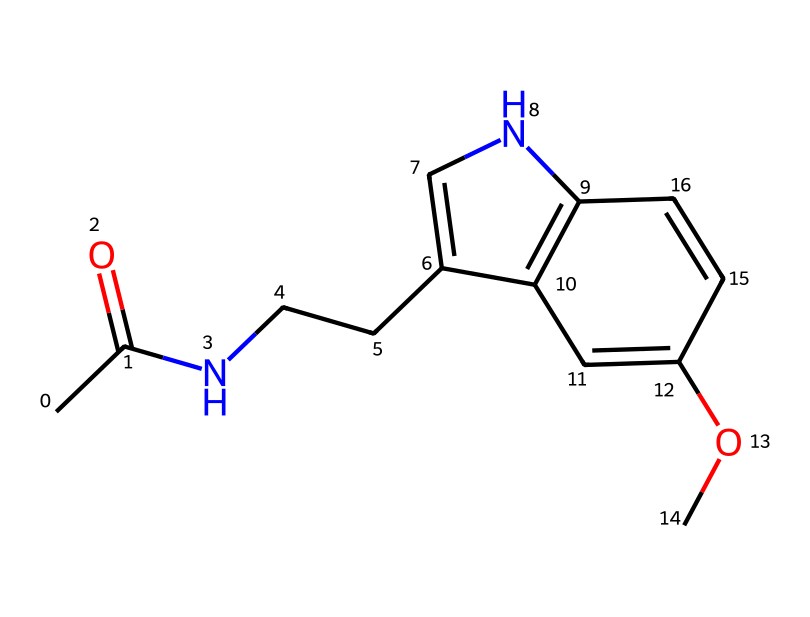how many carbon atoms are in the structure? By examining the SMILES representation, we can count the number of 'C' characters, which represent carbon atoms. In this case, there are 11 carbon atoms present in the structure.
Answer: 11 what is the functional group present in melatonin? Looking at the structure, we can identify that there is an amide group (-C(=O)N-) at the beginning of the SMILES representation, which is a key functional group in melatonin responsible for its biological activity.
Answer: amide what is the total number of nitrogen atoms in this chemical? In the SMILES representation, the nitrogen atoms are represented by the 'N' characters. By counting them, we find that there are 2 nitrogen atoms in the structure of melatonin.
Answer: 2 which bond type is primarily present between carbon and nitrogen in melatonin? The connection between carbon and nitrogen in the amide functional group indicates a covalent bond, which is typically present in organic molecules like melatonin.
Answer: covalent does melatonin contain a methoxy group? The presence of the structure 'OC' in the SMILES indicates a methoxy group (-OCH3), confirming that melatonin indeed contains this functional group characterized by a carbon atom bonded to an oxygen atom.
Answer: yes what is the molecular weight of melatonin? To determine the molecular weight, we would need to calculate it based on the number of each type of atom present in the structure, specifically those counted as 11 carbons, 2 nitrogens, and 13 hydrogens, yielding a molecular weight of approximately 232.3 g/mol.
Answer: 232.3 g/mol 